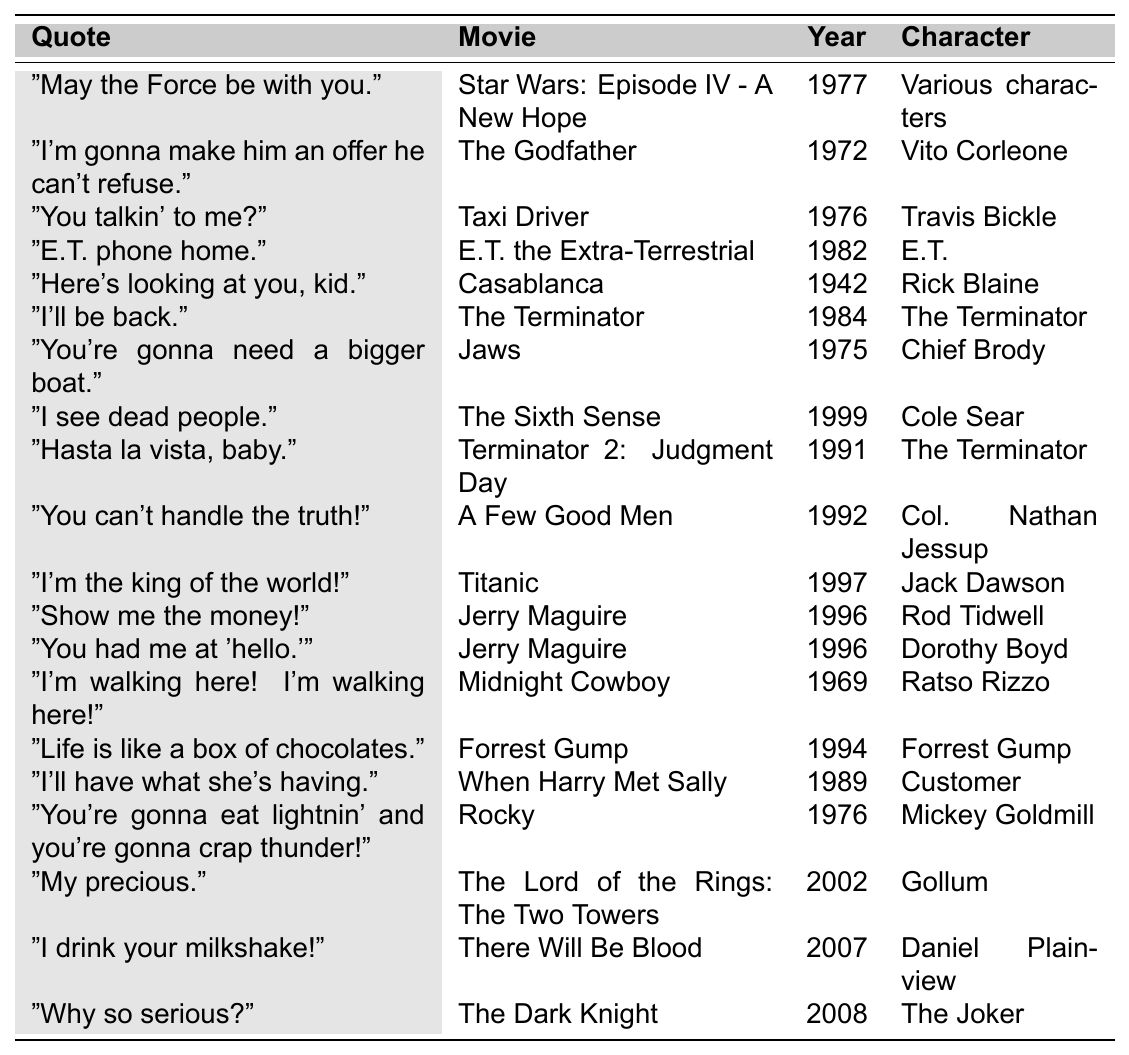What is the quote from "The Godfather"? By locating the row for "The Godfather" in the table, I can see that the associated quote is "I'm gonna make him an offer he can't refuse."
Answer: "I'm gonna make him an offer he can't refuse." Which character says "You talkin' to me?" The quote "You talkin' to me?" is linked to the character Travis Bickle in the movie "Taxi Driver" as shown in the table.
Answer: Travis Bickle In what year was "E.T. the Extra-Terrestrial" released? The table specifies the release year of "E.T. the Extra-Terrestrial" as 1982 listed under the respective movie title.
Answer: 1982 What is the popularity score of the quote "I'll be back."? The quote "I'll be back." from "The Terminator" has a popularity score of 91 according to the table.
Answer: 91 Which movie has the highest popularity score? Scanning through the popularity scores, "Star Wars: Episode IV - A New Hope" has the highest score of 98, making it the most quoted.
Answer: Star Wars: Episode IV - A New Hope How many quotes in the table are from movies released before 1980? The quotes from movies released before 1980 are from "Casablanca" (1942), "Midnight Cowboy" (1969), "Taxi Driver" (1976), "Jaws" (1975), and "The Godfather" (1972), which totals to 5 quotes.
Answer: 5 Determine the average popularity score of the quotes from "Jerry Maguire". The two quotes from "Jerry Maguire" have popularity scores of 85 and 84. Adding these gives 169, and dividing by 2 gives an average score of 84.5.
Answer: 84.5 Is "Life is like a box of chocolates." quoted from a movie released after 2000? The quote is from "Forrest Gump," which was released in 1994, not after 2000; thus, this statement is false.
Answer: No Which quote has a lower popularity score, "My precious." or "I drink your milkshake!"? "My precious." from "The Lord of the Rings: The Two Towers" has a score of 79 while "I drink your milkshake!" from "There Will Be Blood" has a score of 78. Comparing these, "I drink your milkshake!" has the lower score.
Answer: "I drink your milkshake!" Count the number of quotes attributed to the character "The Terminator". There are two quotes attributed to "The Terminator": "I'll be back." from "The Terminator" and "Hasta la vista, baby." from "Terminator 2: Judgment Day." Thus, the count is 2.
Answer: 2 